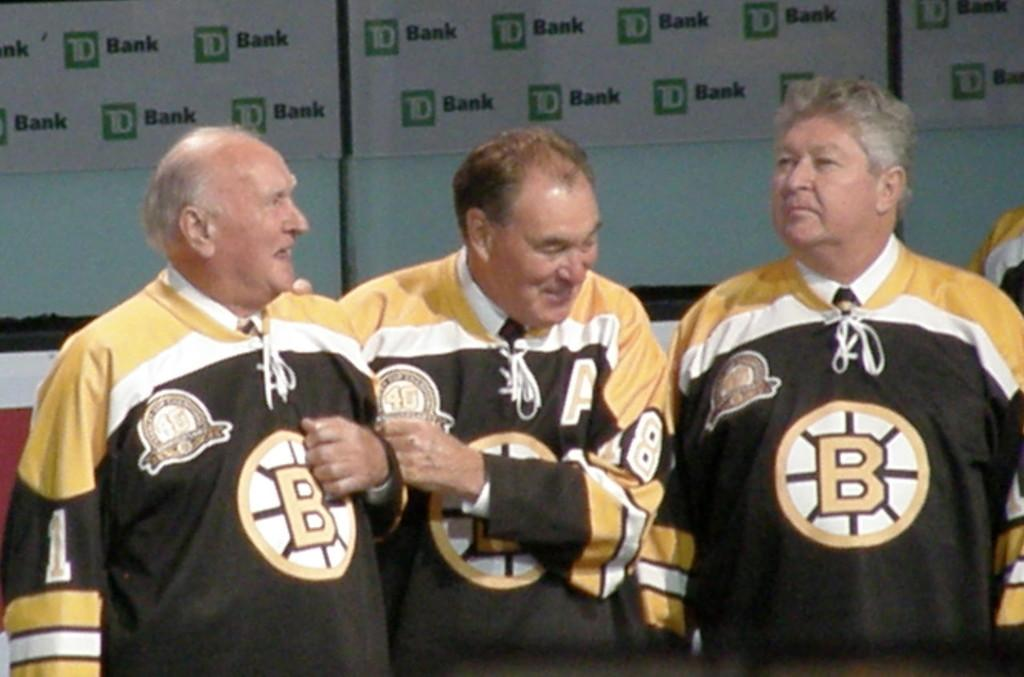<image>
Relay a brief, clear account of the picture shown. Former players being honored and JD bank banners in the background. 